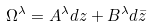<formula> <loc_0><loc_0><loc_500><loc_500>\Omega ^ { \lambda } = A ^ { \lambda } d z + B ^ { \lambda } d { \bar { z } }</formula> 